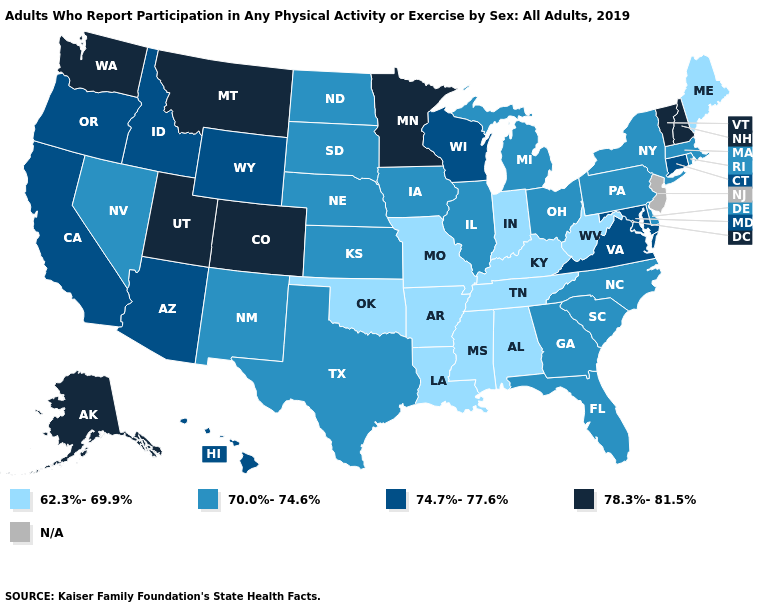Which states hav the highest value in the West?
Concise answer only. Alaska, Colorado, Montana, Utah, Washington. Among the states that border Michigan , does Wisconsin have the highest value?
Keep it brief. Yes. Among the states that border Rhode Island , which have the highest value?
Quick response, please. Connecticut. Does the first symbol in the legend represent the smallest category?
Give a very brief answer. Yes. What is the value of Nebraska?
Concise answer only. 70.0%-74.6%. Name the states that have a value in the range N/A?
Answer briefly. New Jersey. Among the states that border New Jersey , which have the highest value?
Give a very brief answer. Delaware, New York, Pennsylvania. Does the first symbol in the legend represent the smallest category?
Write a very short answer. Yes. Does New Mexico have the lowest value in the West?
Write a very short answer. Yes. Among the states that border Missouri , which have the highest value?
Concise answer only. Illinois, Iowa, Kansas, Nebraska. Which states have the highest value in the USA?
Short answer required. Alaska, Colorado, Minnesota, Montana, New Hampshire, Utah, Vermont, Washington. What is the value of North Carolina?
Give a very brief answer. 70.0%-74.6%. Does Nevada have the lowest value in the West?
Keep it brief. Yes. What is the highest value in states that border Maryland?
Give a very brief answer. 74.7%-77.6%. 